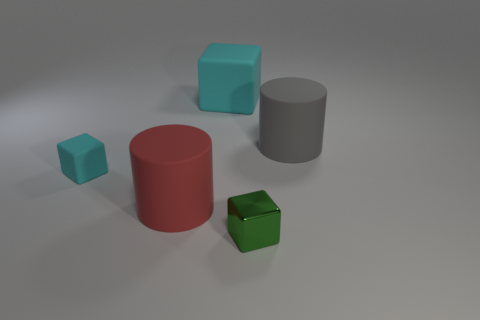Subtract all rubber cubes. How many cubes are left? 1 Subtract all cyan balls. How many cyan cubes are left? 2 Add 3 green objects. How many objects exist? 8 Subtract all cylinders. How many objects are left? 3 Subtract all blue blocks. Subtract all green spheres. How many blocks are left? 3 Add 5 cyan matte objects. How many cyan matte objects are left? 7 Add 5 tiny yellow shiny objects. How many tiny yellow shiny objects exist? 5 Subtract 0 purple cylinders. How many objects are left? 5 Subtract all matte cylinders. Subtract all yellow spheres. How many objects are left? 3 